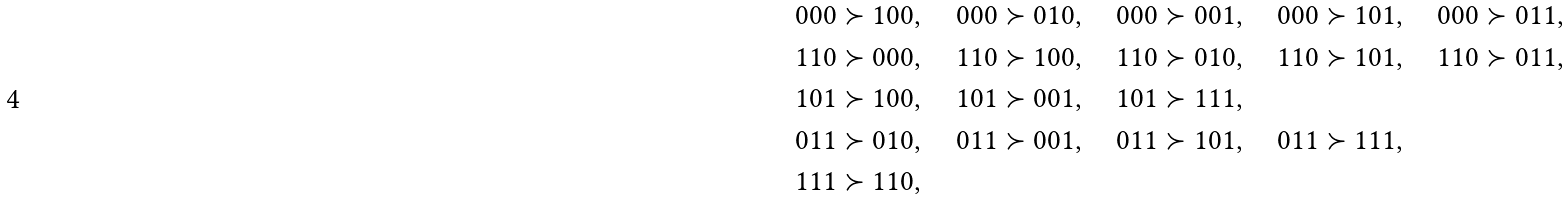<formula> <loc_0><loc_0><loc_500><loc_500>& 0 0 0 \succ 1 0 0 , \quad 0 0 0 \succ 0 1 0 , \quad 0 0 0 \succ 0 0 1 , \quad 0 0 0 \succ 1 0 1 , \quad 0 0 0 \succ 0 1 1 , \\ & 1 1 0 \succ 0 0 0 , \quad 1 1 0 \succ 1 0 0 , \quad 1 1 0 \succ 0 1 0 , \quad 1 1 0 \succ 1 0 1 , \quad 1 1 0 \succ 0 1 1 , \\ & 1 0 1 \succ 1 0 0 , \quad 1 0 1 \succ 0 0 1 , \quad 1 0 1 \succ 1 1 1 , \\ & 0 1 1 \succ 0 1 0 , \quad 0 1 1 \succ 0 0 1 , \quad 0 1 1 \succ 1 0 1 , \quad 0 1 1 \succ 1 1 1 , \\ & 1 1 1 \succ 1 1 0 ,</formula> 